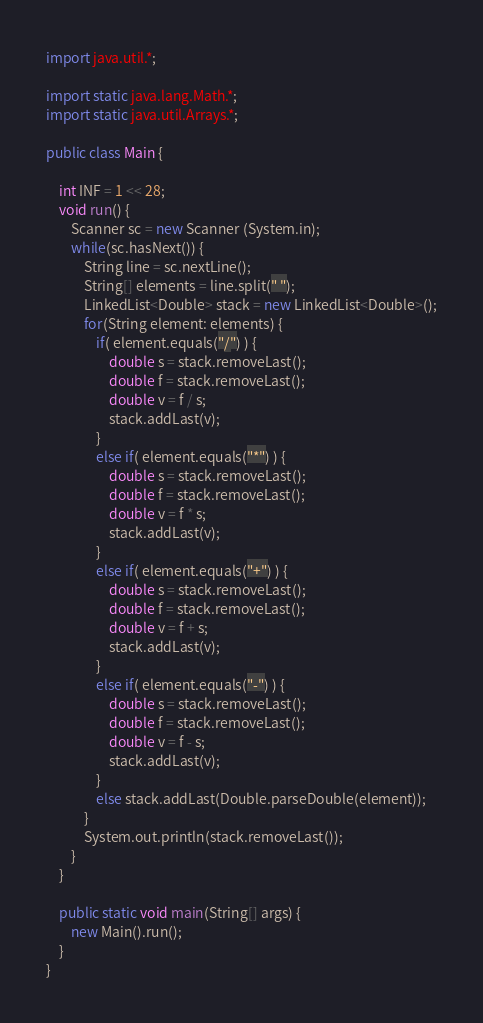Convert code to text. <code><loc_0><loc_0><loc_500><loc_500><_Java_>
import java.util.*;

import static java.lang.Math.*;
import static java.util.Arrays.*;

public class Main {

	int INF = 1 << 28;
	void run() {
		Scanner sc = new Scanner (System.in);
		while(sc.hasNext()) {
			String line = sc.nextLine();
			String[] elements = line.split(" ");
			LinkedList<Double> stack = new LinkedList<Double>();
			for(String element: elements) {
				if( element.equals("/") ) {
					double s = stack.removeLast();
					double f = stack.removeLast();
					double v = f / s;
					stack.addLast(v);
				}
				else if( element.equals("*") ) {
					double s = stack.removeLast();
					double f = stack.removeLast();
					double v = f * s;
					stack.addLast(v);
				}
				else if( element.equals("+") ) {
					double s = stack.removeLast();
					double f = stack.removeLast();
					double v = f + s;
					stack.addLast(v);
				}
				else if( element.equals("-") ) {
					double s = stack.removeLast();
					double f = stack.removeLast();
					double v = f - s;
					stack.addLast(v);
				}
				else stack.addLast(Double.parseDouble(element));
			}
			System.out.println(stack.removeLast());
		}
	}
	
	public static void main(String[] args) {
		new Main().run();
	}
}</code> 